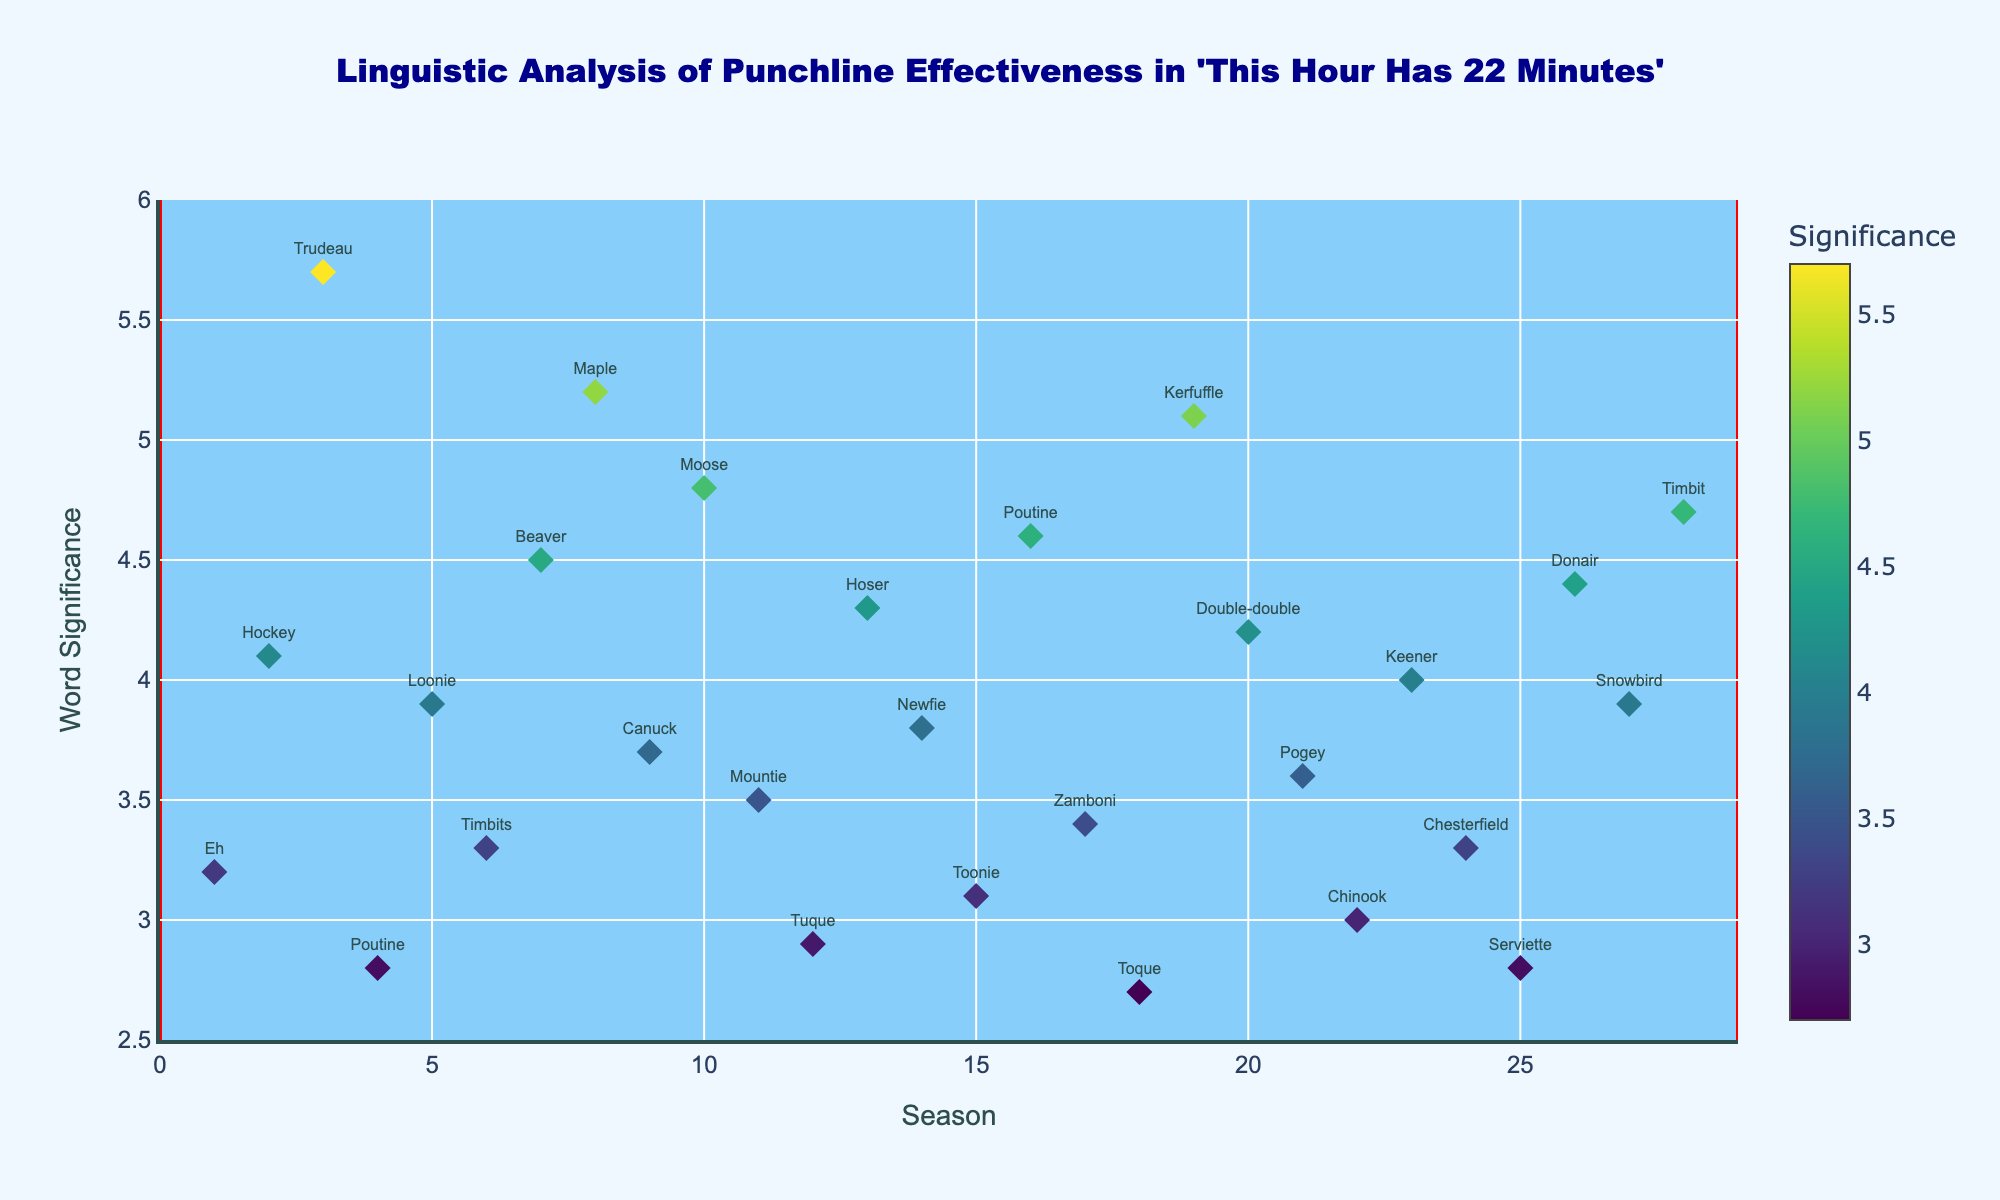What's the title of the plot? The title is located at the top of the plot and is specified in the plot settings. It is displayed in a distinct font size to attract attention.
Answer: Linguistic Analysis of Punchline Effectiveness in 'This Hour Has 22 Minutes' What is the highest word significance value and in which season does it occur? To find the highest word significance value, we need to look at the y-axis and find the maximum point. This maximum point corresponds to the word "Trudeau" with a significance value of 5.7.
Answer: 5.7, Season 3 Which words have a significance value above 5.0? To answer this, locate all points on the plot above the 5.0 mark on the y-axis and note their corresponding words. These words are "Trudeau", "Maple", and "Kerfuffle" with significance values of 5.7, 5.2, and 5.1 respectively.
Answer: Trudeau, Maple, Kerfuffle How does the significance of "Poutine" change across seasons? Find the two instances of "Poutine" on the plot, notice their corresponding seasons and significance values. The plot shows that "Poutine" appears with a significance of 2.8 in Season 4 and increases to 4.6 in Season 16.
Answer: Increases from 2.8 in Season 4 to 4.6 in Season 16 Which season has the word with the lowest significance value and what is that word? Look for the point with the lowest y-axis value on the plot, which corresponds to a value of 2.7. This point represents the word "Toque" in Season 18.
Answer: Season 18, Toque Rank the words in Season 7 by their significance values. To rank the words, identify all words from Season 7 on the plot and compare their y-axis (significance) values. Only "Beaver" appears in Season 7 with a significance of 4.5.
Answer: Beaver - 4.5 Which word is represented by the purple color and in which season does it occur? The color scale moves from lighter to darker, with higher values generally being represented by more intense colors. "Maple" shows the darkest purple, appearing in Season 8 with a significance of 5.2.
Answer: Maple, Season 8 How many words have a significance value between 3.0 and 4.0? Count the number of points on the plot where the y-axis values fall between 3.0 and 4.0. The words in this range are "Eh", "Loonie", "Timbits", "Canuck", "Mountie", "Tuque", "Toonie", "Zamboni", "Pogey", and "Chinook", totalling 10 words.
Answer: 10 words Between Seasons 10 and 15, which word has the highest significance and what is its value? Isolate the points on the plot that represent Seasons 10 through 15 and identify the one with the highest y-axis value. "Hoser" in Season 13 has the highest significance value with 4.3.
Answer: Hoser, 4.3 